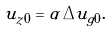Convert formula to latex. <formula><loc_0><loc_0><loc_500><loc_500>u _ { z 0 } = \alpha \, \Delta u _ { g 0 } .</formula> 